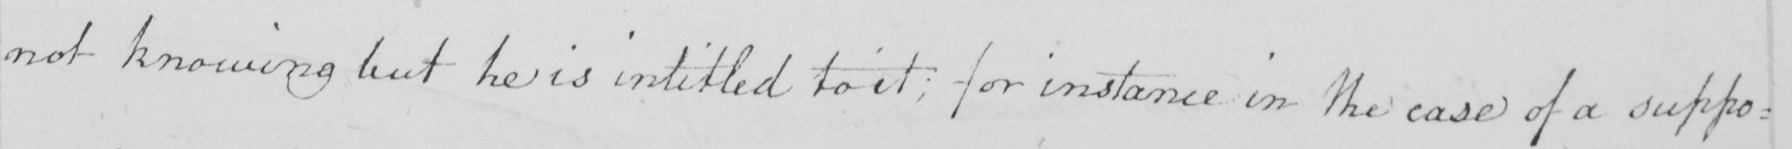Transcribe the text shown in this historical manuscript line. not knowing but he is intitled to it ; for instance in the case of a suppo= 